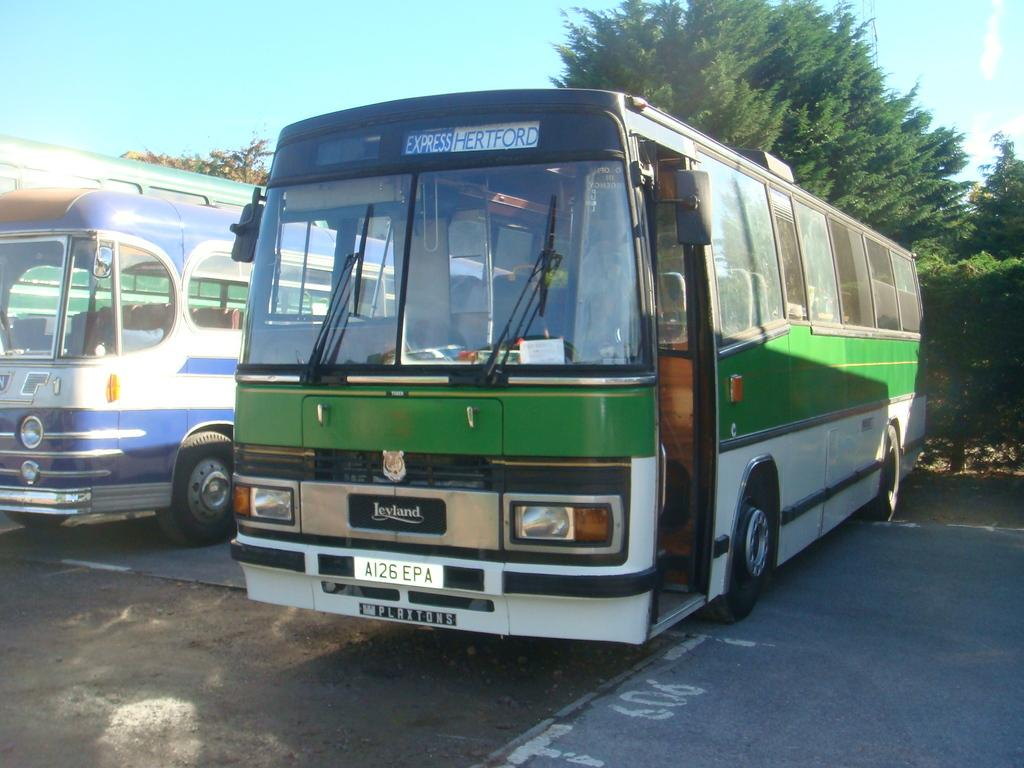Provide a one-sentence caption for the provided image. The old green and white bus is listed as following the express Hertford route. 